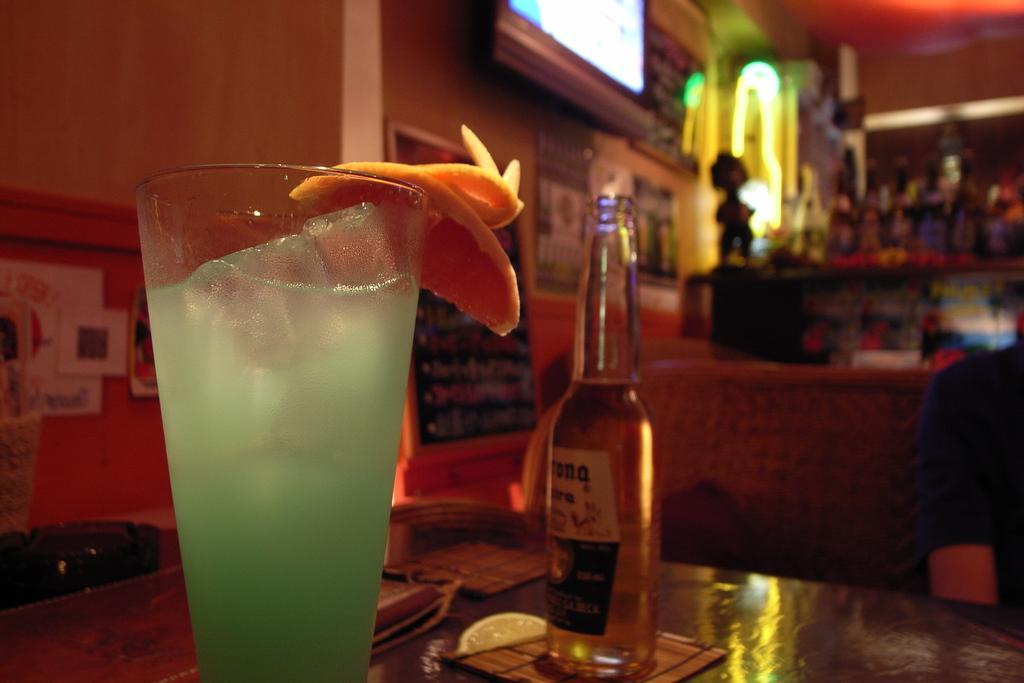Could you give a brief overview of what you see in this image? The picture is taken inside a room. In the foreground there is glass with drink there is a bottle beside it,there is a slice of lemon. These all are on a table. In the right side some part of a man is visible. In the background there are many bottle. There is a screen mounted on the wall. 